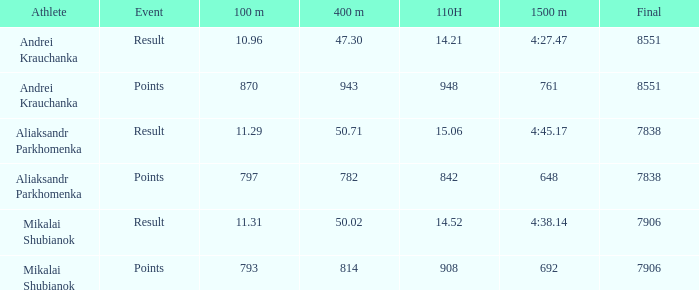What was the 400m featuring a 110h surpassing 1 1.0. 